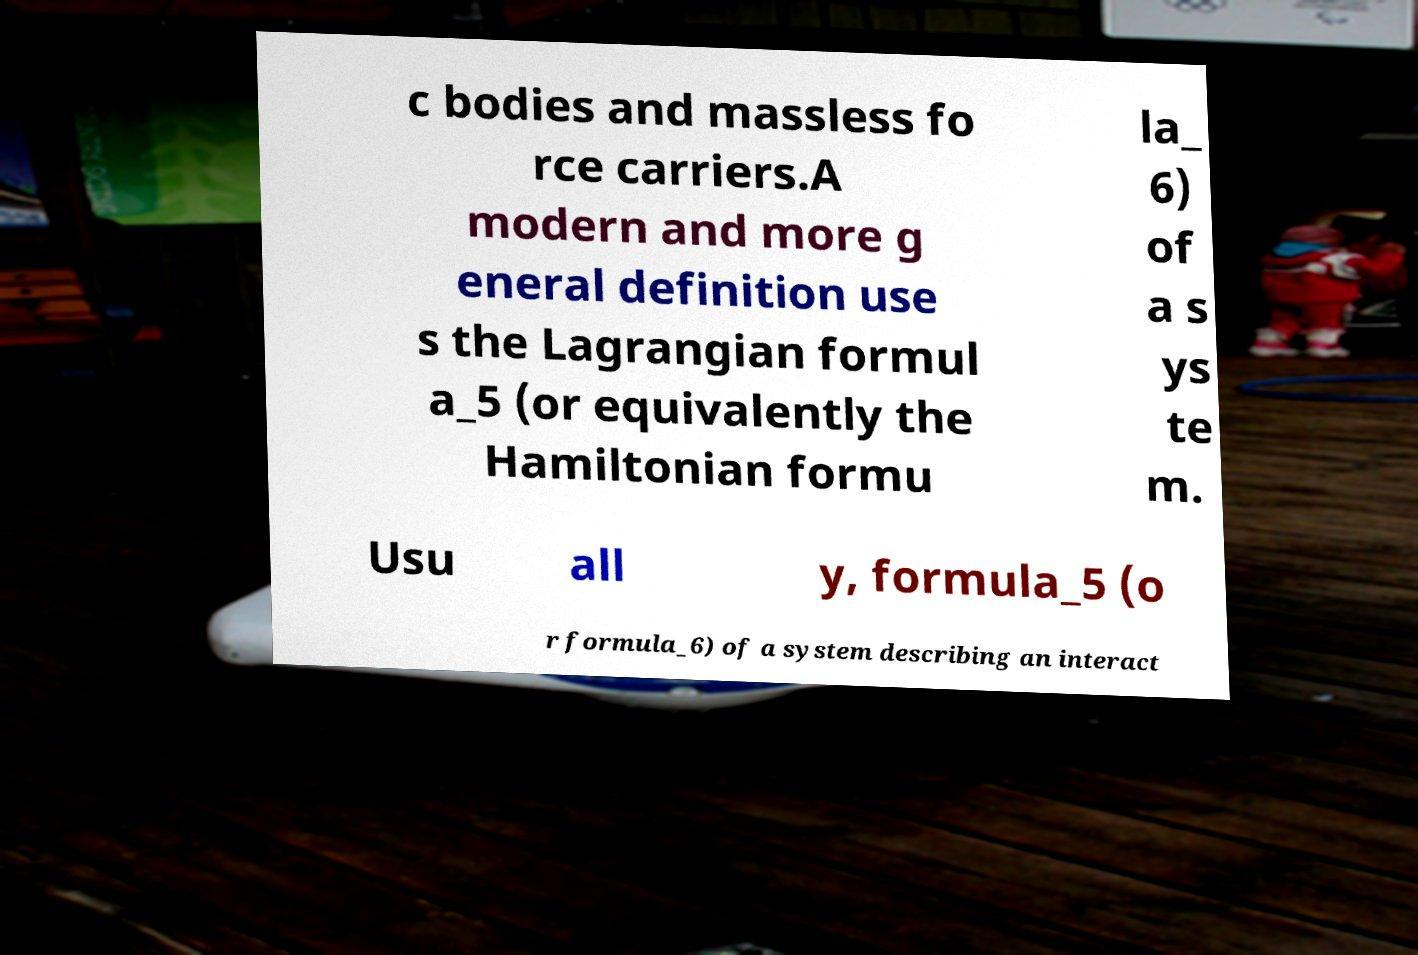Could you extract and type out the text from this image? c bodies and massless fo rce carriers.A modern and more g eneral definition use s the Lagrangian formul a_5 (or equivalently the Hamiltonian formu la_ 6) of a s ys te m. Usu all y, formula_5 (o r formula_6) of a system describing an interact 